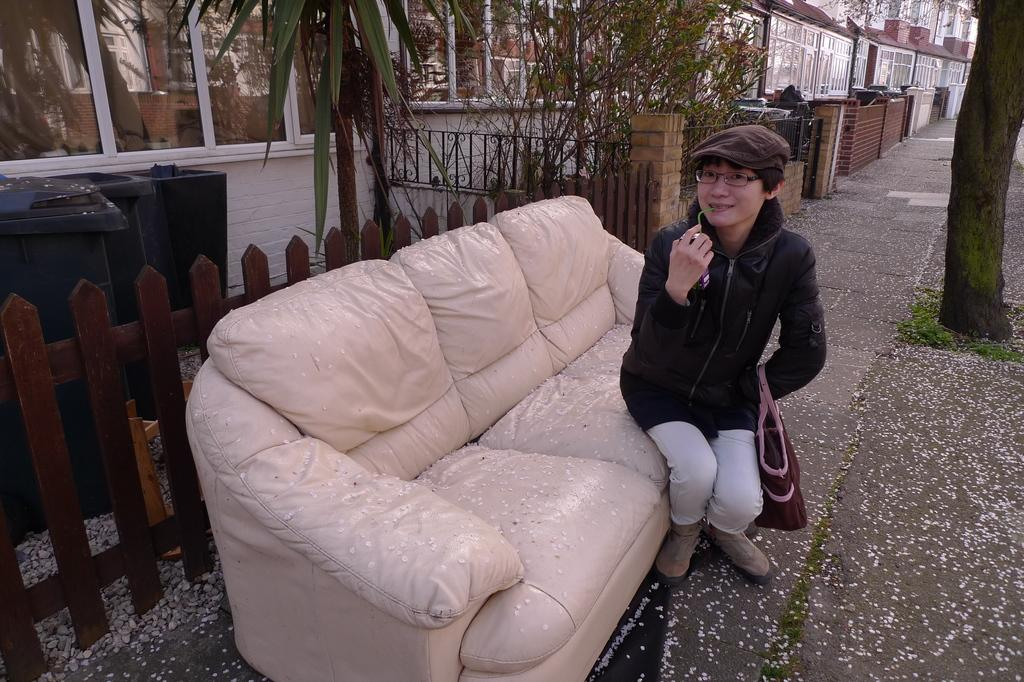What is the woman in the image doing? The woman is sitting on the sofa in the image. What can be seen on the right side of the image? There is a tree on the right side of the image. What type of vegetation is present in the image? There are plants in the image. What type of structures can be seen in the image? There are buildings in the image. What type of barrier is visible in the image? There is a fencing in the image. How many ladybugs are crawling on the woman's arm in the image? There are no ladybugs present in the image; the woman's arm is not visible. What type of basin is used for watering the plants in the image? There is no basin visible in the image; the plants are not being watered. 